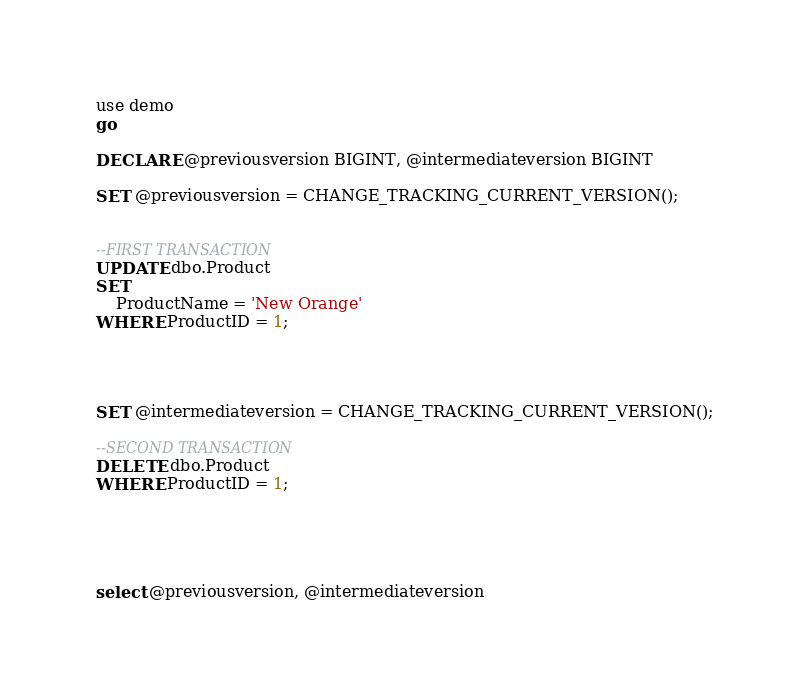Convert code to text. <code><loc_0><loc_0><loc_500><loc_500><_SQL_>use demo
go

DECLARE @previousversion BIGINT, @intermediateversion BIGINT

SET @previousversion = CHANGE_TRACKING_CURRENT_VERSION();


--FIRST TRANSACTION
UPDATE dbo.Product
SET
	ProductName = 'New Orange'
WHERE ProductID = 1;




SET @intermediateversion = CHANGE_TRACKING_CURRENT_VERSION();

--SECOND TRANSACTION
DELETE dbo.Product
WHERE ProductID = 1;





select @previousversion, @intermediateversion</code> 